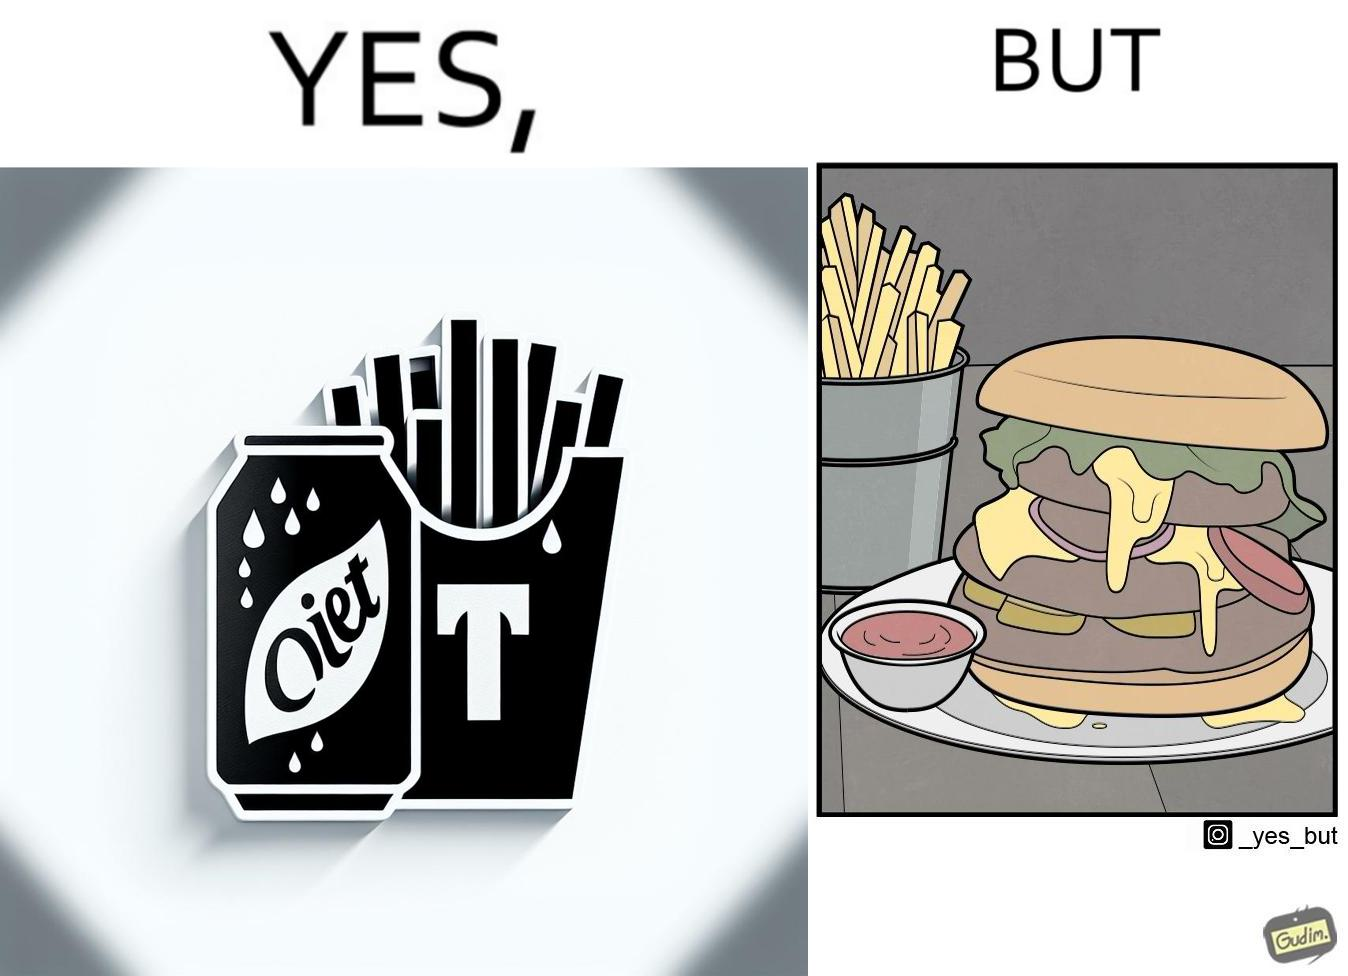Why is this image considered satirical? The image is ironic, because on one hand the person is consuming diet cola suggesting low on sugar as per label meaning the person is health-conscious but on the other hand the same one is having huge size burger with french fries which suggests the person to be health-ignorant 